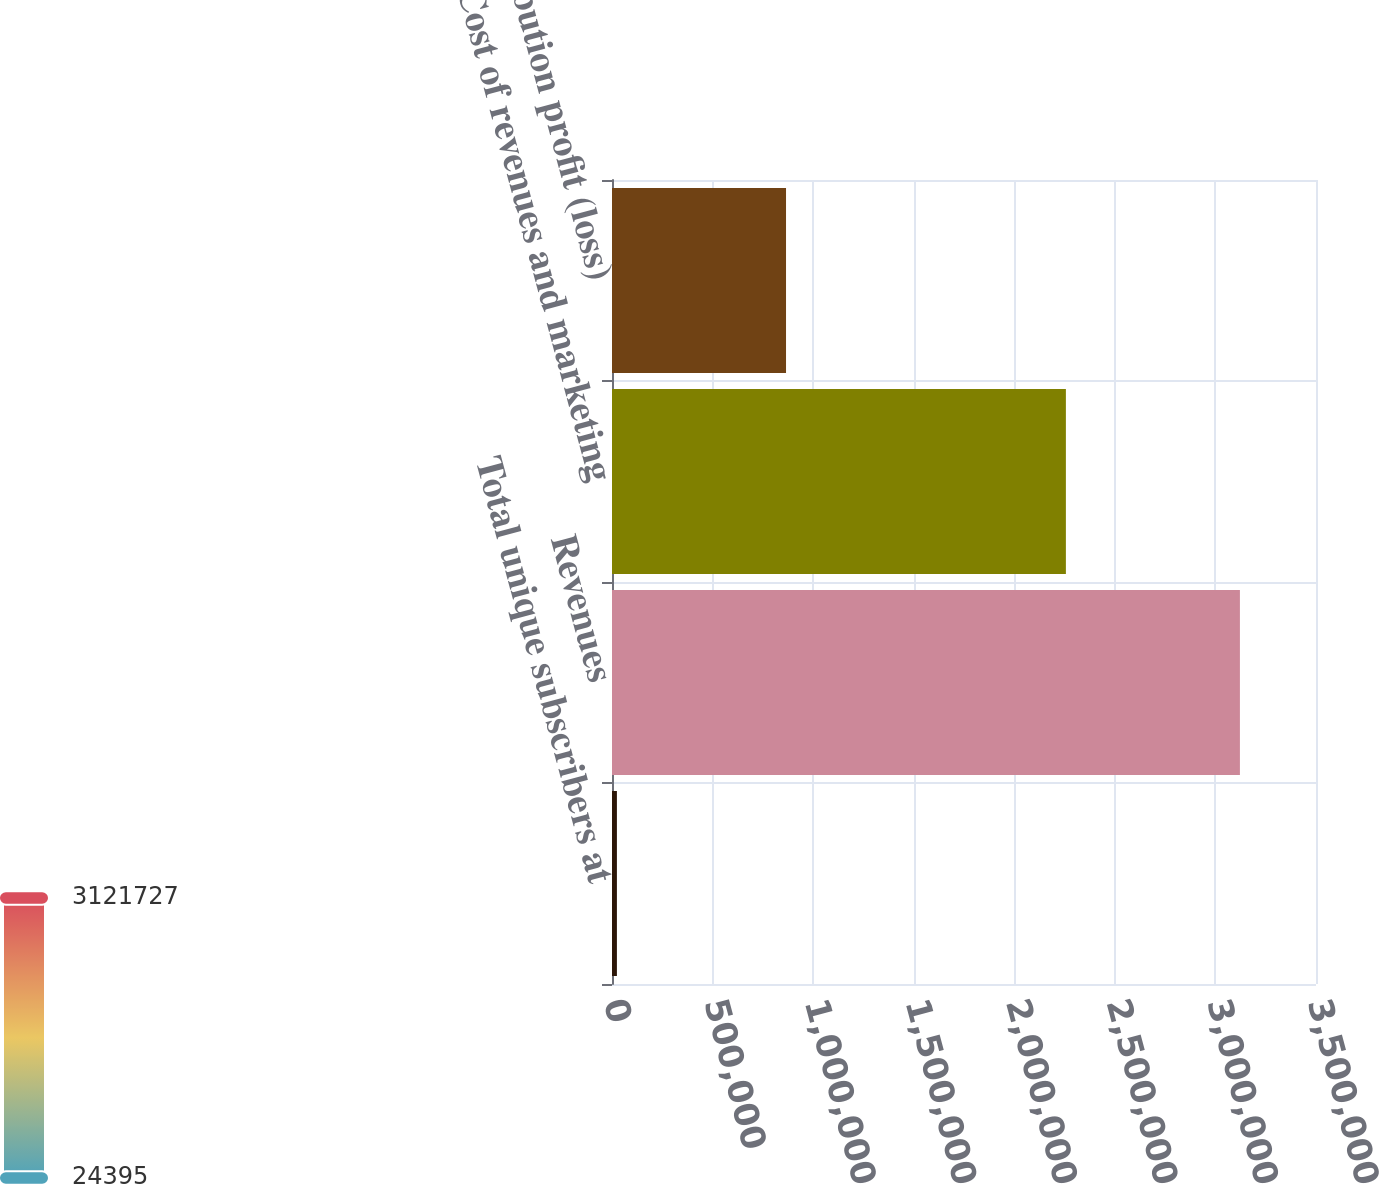Convert chart. <chart><loc_0><loc_0><loc_500><loc_500><bar_chart><fcel>Total unique subscribers at<fcel>Revenues<fcel>Cost of revenues and marketing<fcel>Contribution profit (loss)<nl><fcel>24395<fcel>3.12173e+06<fcel>2.25654e+06<fcel>865187<nl></chart> 